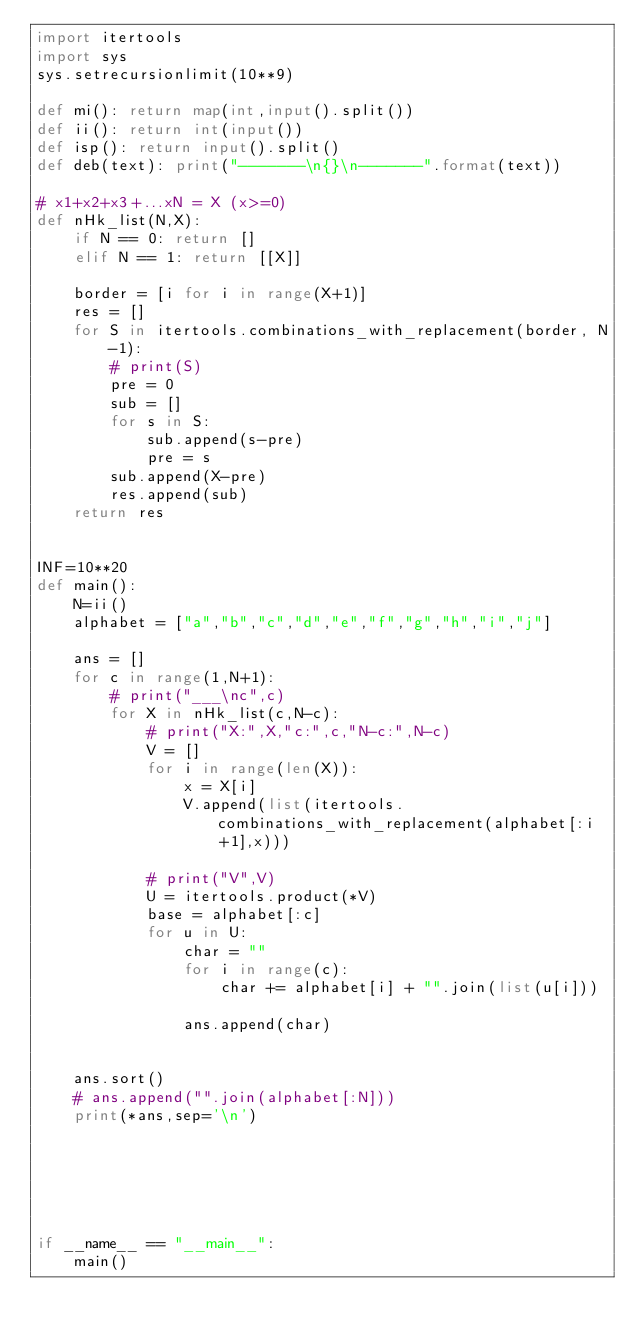<code> <loc_0><loc_0><loc_500><loc_500><_Python_>import itertools
import sys
sys.setrecursionlimit(10**9)

def mi(): return map(int,input().split())
def ii(): return int(input())
def isp(): return input().split()
def deb(text): print("-------\n{}\n-------".format(text))

# x1+x2+x3+...xN = X (x>=0) 
def nHk_list(N,X):
    if N == 0: return []
    elif N == 1: return [[X]]

    border = [i for i in range(X+1)]
    res = []
    for S in itertools.combinations_with_replacement(border, N-1):
        # print(S)
        pre = 0
        sub = []
        for s in S:
            sub.append(s-pre)
            pre = s
        sub.append(X-pre)
        res.append(sub)
    return res


INF=10**20
def main():
    N=ii()
    alphabet = ["a","b","c","d","e","f","g","h","i","j"]

    ans = []
    for c in range(1,N+1):
        # print("___\nc",c)
        for X in nHk_list(c,N-c):
            # print("X:",X,"c:",c,"N-c:",N-c)
            V = []
            for i in range(len(X)):
                x = X[i]
                V.append(list(itertools.combinations_with_replacement(alphabet[:i+1],x)))

            # print("V",V)
            U = itertools.product(*V)
            base = alphabet[:c]
            for u in U:
                char = ""
                for i in range(c):
                    char += alphabet[i] + "".join(list(u[i]))
        
                ans.append(char)
        
    
    ans.sort()
    # ans.append("".join(alphabet[:N]))
    print(*ans,sep='\n')

            
            

        

if __name__ == "__main__":
    main()</code> 